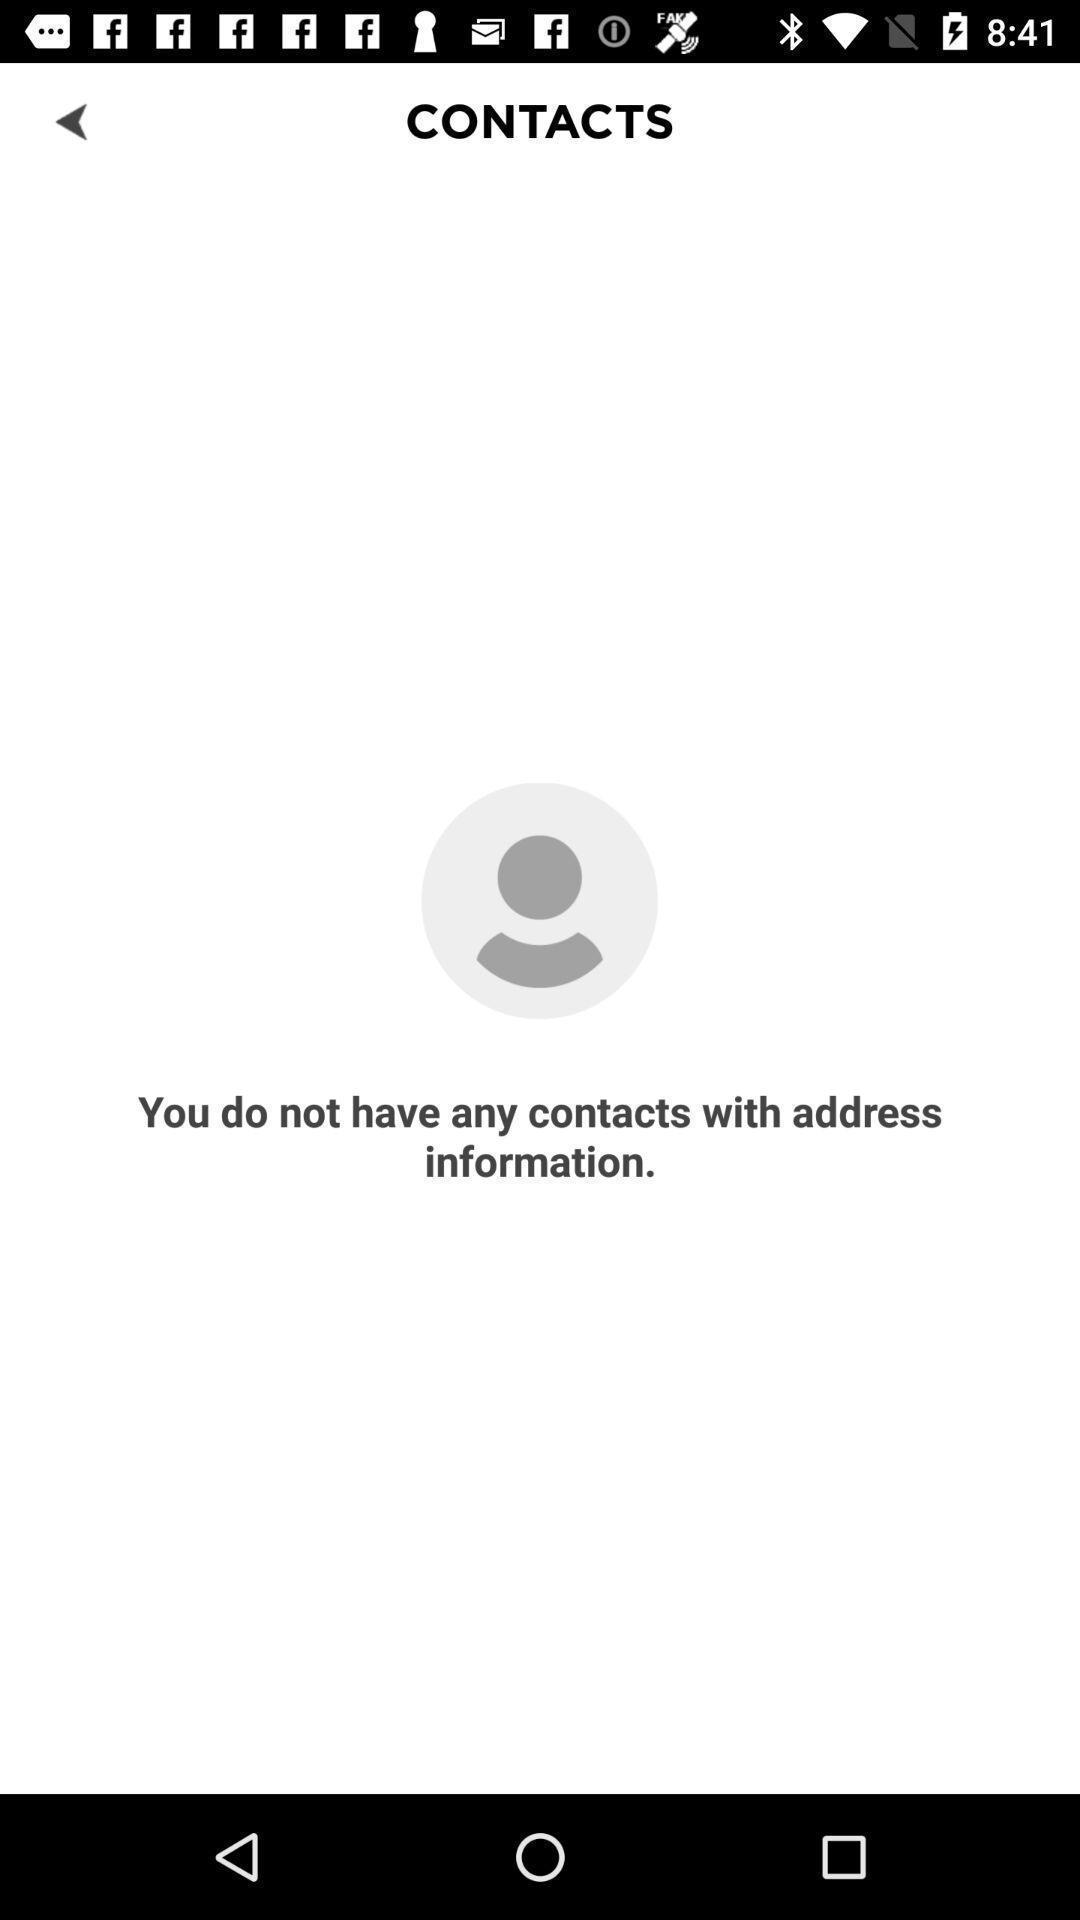Give me a summary of this screen capture. Page displaying no contact details in app. 